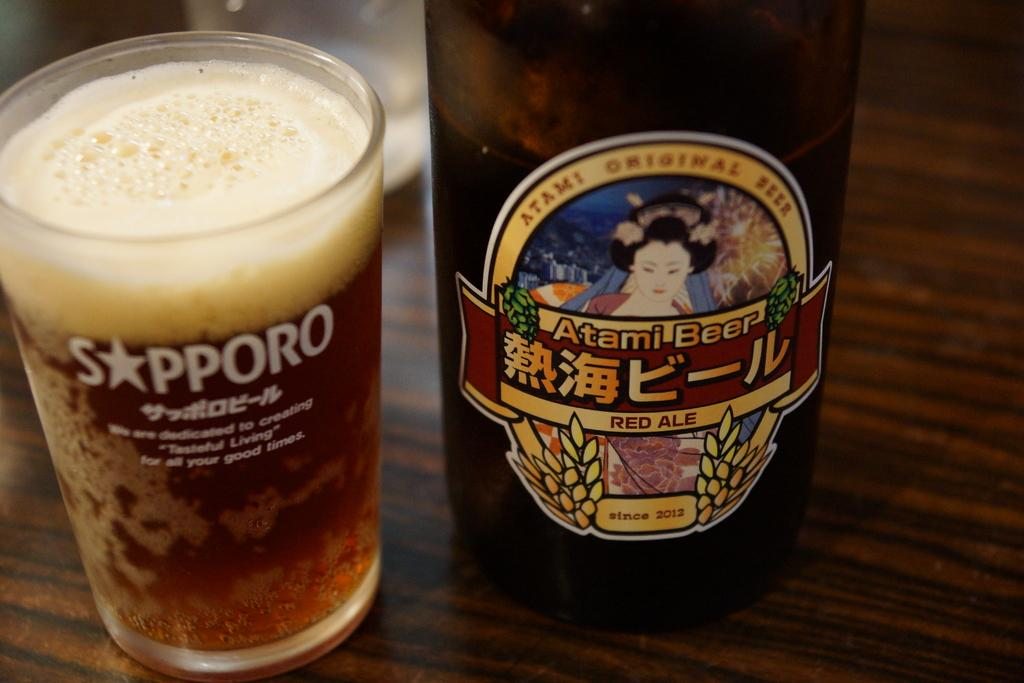Provide a one-sentence caption for the provided image. A glass of atami beer in a sapporo glass. 